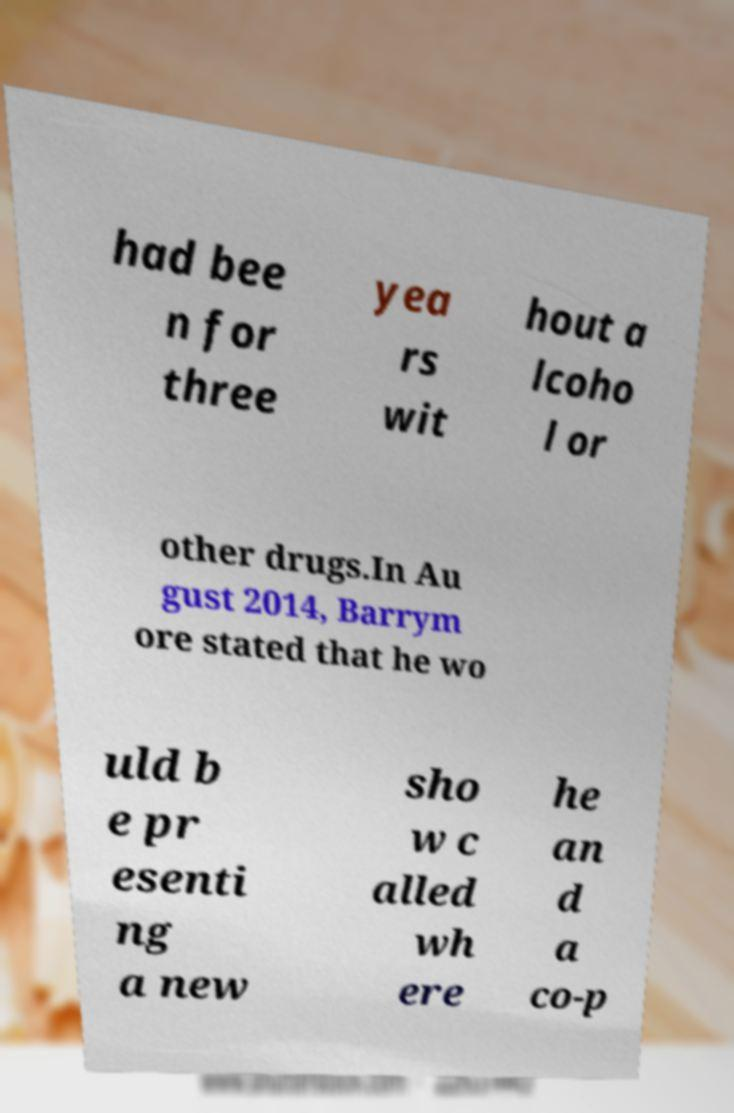I need the written content from this picture converted into text. Can you do that? had bee n for three yea rs wit hout a lcoho l or other drugs.In Au gust 2014, Barrym ore stated that he wo uld b e pr esenti ng a new sho w c alled wh ere he an d a co-p 